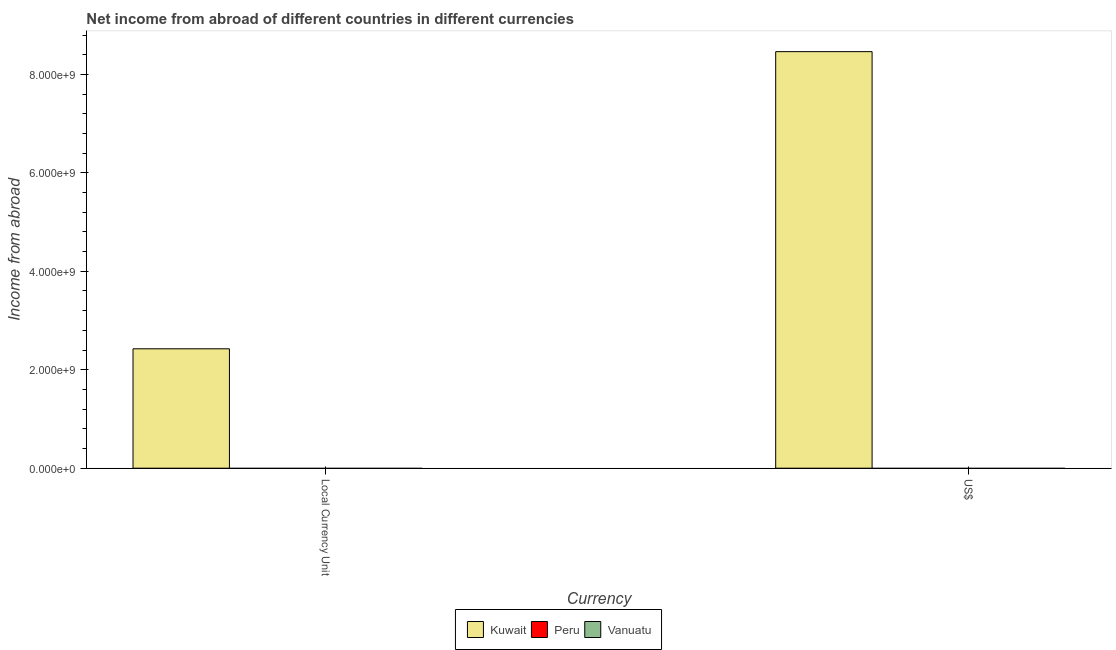How many different coloured bars are there?
Give a very brief answer. 1. Are the number of bars per tick equal to the number of legend labels?
Ensure brevity in your answer.  No. How many bars are there on the 1st tick from the right?
Give a very brief answer. 1. What is the label of the 1st group of bars from the left?
Make the answer very short. Local Currency Unit. What is the income from abroad in us$ in Kuwait?
Your answer should be compact. 8.46e+09. Across all countries, what is the maximum income from abroad in us$?
Offer a terse response. 8.46e+09. In which country was the income from abroad in us$ maximum?
Provide a succinct answer. Kuwait. What is the total income from abroad in us$ in the graph?
Offer a very short reply. 8.46e+09. What is the difference between the income from abroad in constant 2005 us$ in Kuwait and the income from abroad in us$ in Vanuatu?
Offer a very short reply. 2.43e+09. What is the average income from abroad in us$ per country?
Keep it short and to the point. 2.82e+09. What is the difference between the income from abroad in us$ and income from abroad in constant 2005 us$ in Kuwait?
Provide a short and direct response. 6.04e+09. Are all the bars in the graph horizontal?
Offer a terse response. No. How many countries are there in the graph?
Give a very brief answer. 3. Where does the legend appear in the graph?
Offer a very short reply. Bottom center. How many legend labels are there?
Provide a short and direct response. 3. What is the title of the graph?
Ensure brevity in your answer.  Net income from abroad of different countries in different currencies. What is the label or title of the X-axis?
Offer a terse response. Currency. What is the label or title of the Y-axis?
Offer a very short reply. Income from abroad. What is the Income from abroad of Kuwait in Local Currency Unit?
Your answer should be compact. 2.43e+09. What is the Income from abroad of Vanuatu in Local Currency Unit?
Provide a short and direct response. 0. What is the Income from abroad of Kuwait in US$?
Make the answer very short. 8.46e+09. What is the Income from abroad in Peru in US$?
Provide a succinct answer. 0. What is the Income from abroad of Vanuatu in US$?
Give a very brief answer. 0. Across all Currency, what is the maximum Income from abroad of Kuwait?
Your answer should be very brief. 8.46e+09. Across all Currency, what is the minimum Income from abroad in Kuwait?
Provide a short and direct response. 2.43e+09. What is the total Income from abroad of Kuwait in the graph?
Offer a very short reply. 1.09e+1. What is the total Income from abroad in Peru in the graph?
Your response must be concise. 0. What is the total Income from abroad of Vanuatu in the graph?
Make the answer very short. 0. What is the difference between the Income from abroad in Kuwait in Local Currency Unit and that in US$?
Your answer should be compact. -6.04e+09. What is the average Income from abroad of Kuwait per Currency?
Your answer should be very brief. 5.44e+09. What is the average Income from abroad in Peru per Currency?
Provide a short and direct response. 0. What is the average Income from abroad of Vanuatu per Currency?
Give a very brief answer. 0. What is the ratio of the Income from abroad of Kuwait in Local Currency Unit to that in US$?
Ensure brevity in your answer.  0.29. What is the difference between the highest and the second highest Income from abroad of Kuwait?
Keep it short and to the point. 6.04e+09. What is the difference between the highest and the lowest Income from abroad in Kuwait?
Offer a very short reply. 6.04e+09. 